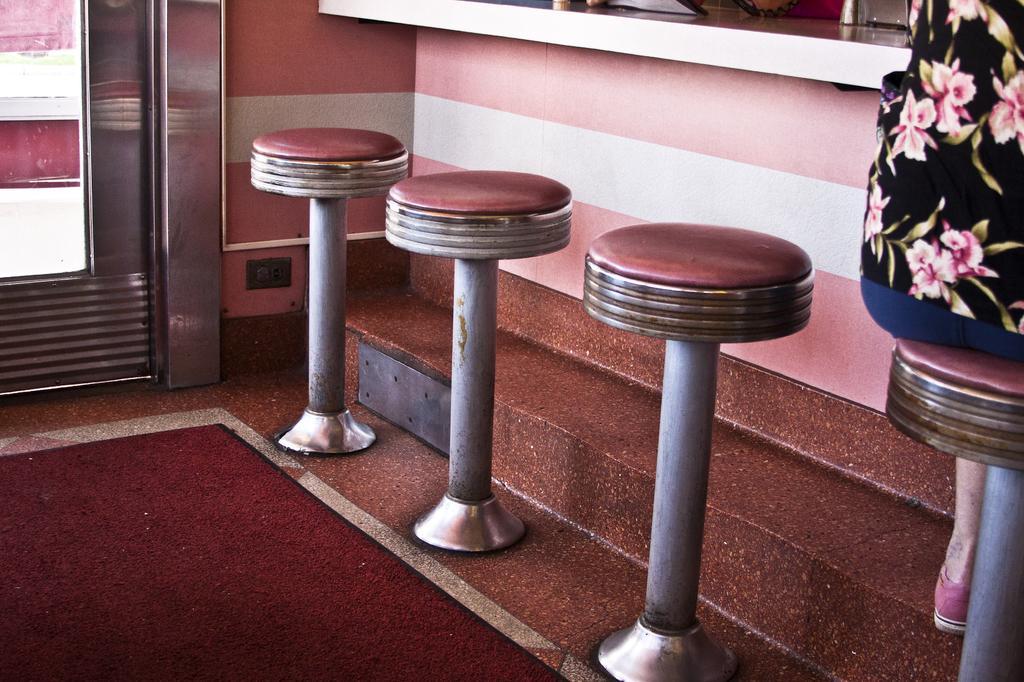Please provide a concise description of this image. In this image in the center there are four stools and one person is sitting on one stool, on the left side there is a glass door and on the right side there is a table. At the bottom there is a red color carpet. 